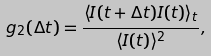<formula> <loc_0><loc_0><loc_500><loc_500>g _ { 2 } ( \Delta t ) = \frac { \langle I ( t + \Delta t ) I ( t ) \rangle _ { t } } { \langle I ( t ) \rangle ^ { 2 } } ,</formula> 